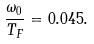Convert formula to latex. <formula><loc_0><loc_0><loc_500><loc_500>\frac { \omega _ { 0 } } { T _ { F } } = 0 . 0 4 5 .</formula> 